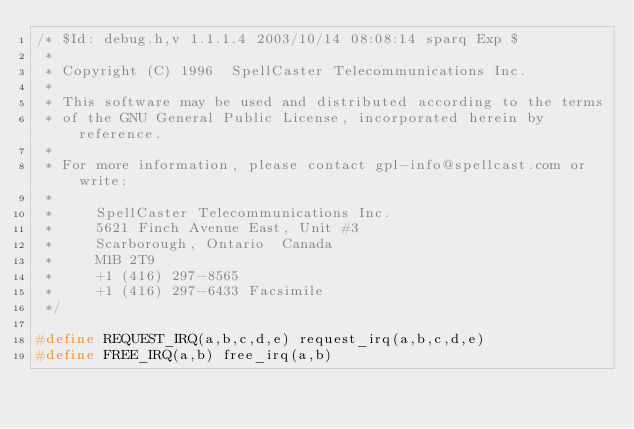Convert code to text. <code><loc_0><loc_0><loc_500><loc_500><_C_>/* $Id: debug.h,v 1.1.1.4 2003/10/14 08:08:14 sparq Exp $
 *
 * Copyright (C) 1996  SpellCaster Telecommunications Inc.
 *
 * This software may be used and distributed according to the terms
 * of the GNU General Public License, incorporated herein by reference.
 *
 * For more information, please contact gpl-info@spellcast.com or write:
 *
 *     SpellCaster Telecommunications Inc.
 *     5621 Finch Avenue East, Unit #3
 *     Scarborough, Ontario  Canada
 *     M1B 2T9
 *     +1 (416) 297-8565
 *     +1 (416) 297-6433 Facsimile
 */

#define REQUEST_IRQ(a,b,c,d,e) request_irq(a,b,c,d,e)
#define FREE_IRQ(a,b) free_irq(a,b)
</code> 